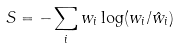Convert formula to latex. <formula><loc_0><loc_0><loc_500><loc_500>S = - \sum _ { i } w _ { i } \log ( w _ { i } / \hat { w } _ { i } )</formula> 